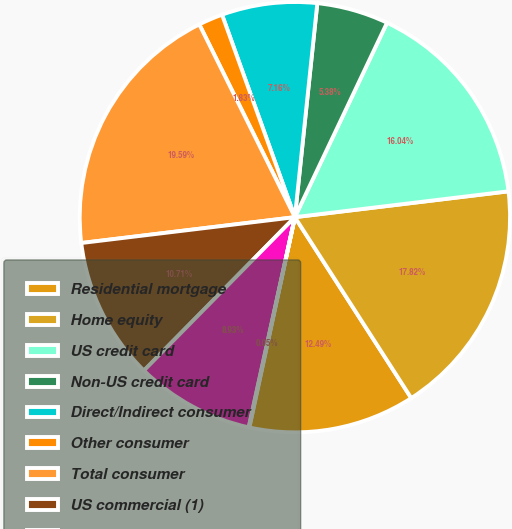<chart> <loc_0><loc_0><loc_500><loc_500><pie_chart><fcel>Residential mortgage<fcel>Home equity<fcel>US credit card<fcel>Non-US credit card<fcel>Direct/Indirect consumer<fcel>Other consumer<fcel>Total consumer<fcel>US commercial (1)<fcel>Commercial real estate<fcel>Commercial lease financing<nl><fcel>12.49%<fcel>17.82%<fcel>16.04%<fcel>5.38%<fcel>7.16%<fcel>1.83%<fcel>19.59%<fcel>10.71%<fcel>8.93%<fcel>0.05%<nl></chart> 